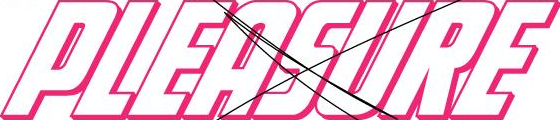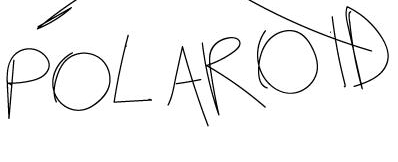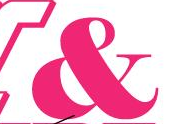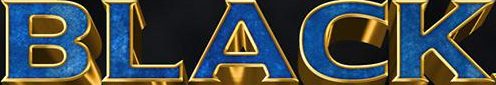What text is displayed in these images sequentially, separated by a semicolon? PLEASURE; POLAROID; &; BLACK 